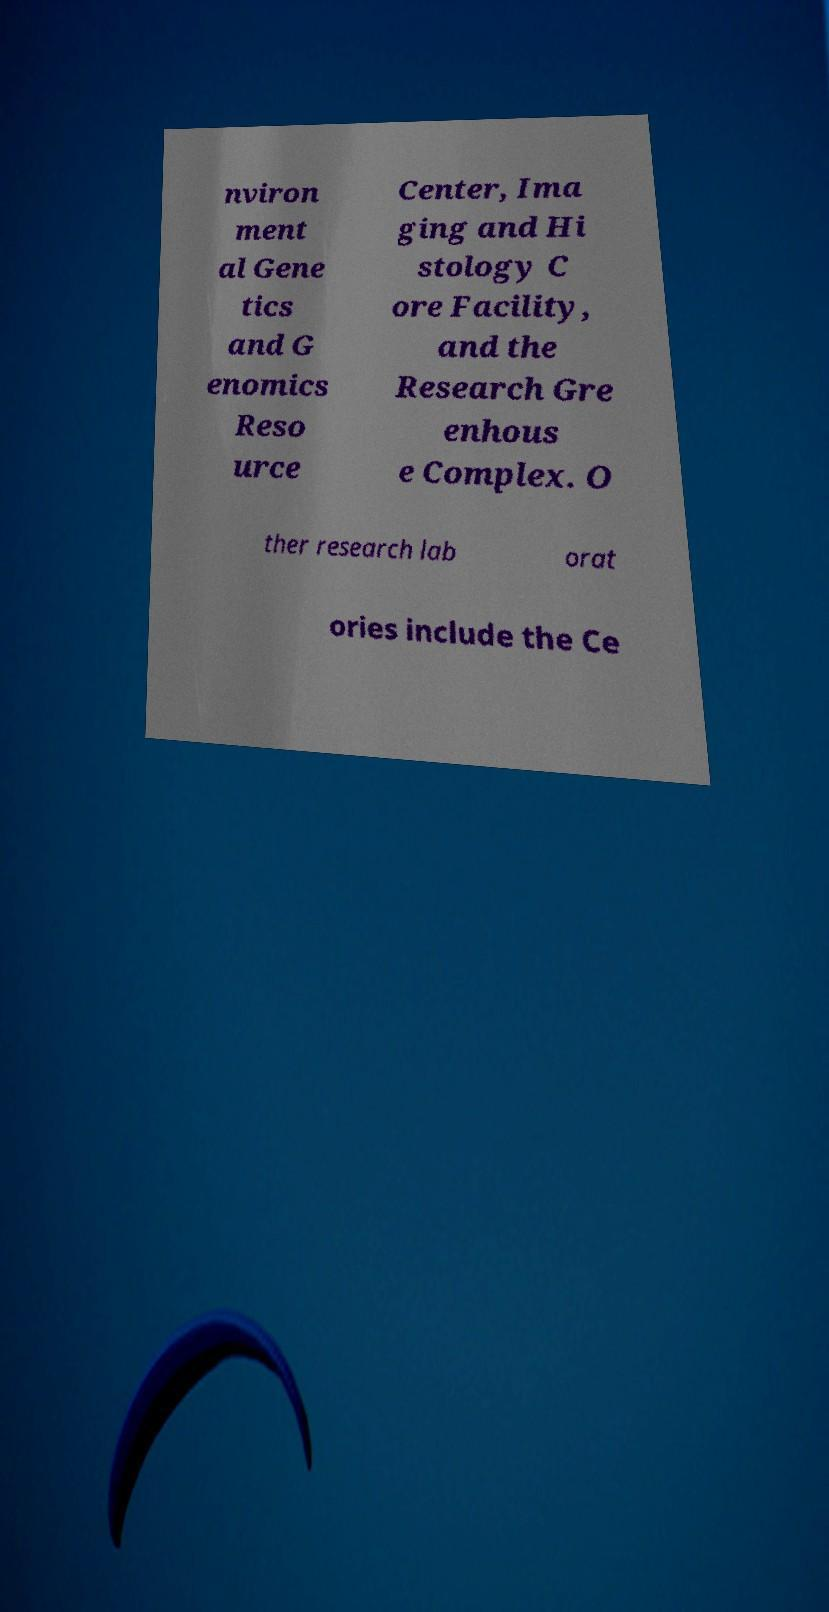Could you assist in decoding the text presented in this image and type it out clearly? nviron ment al Gene tics and G enomics Reso urce Center, Ima ging and Hi stology C ore Facility, and the Research Gre enhous e Complex. O ther research lab orat ories include the Ce 